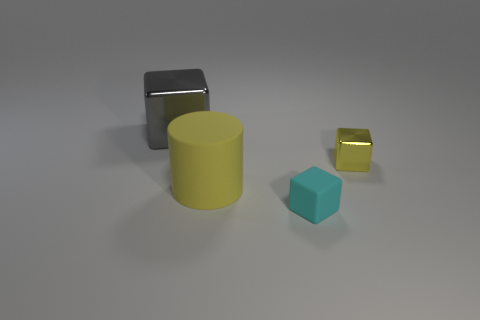Add 1 small yellow metal cylinders. How many objects exist? 5 Subtract all cylinders. How many objects are left? 3 Add 3 big blocks. How many big blocks exist? 4 Subtract 0 gray balls. How many objects are left? 4 Subtract all big yellow objects. Subtract all red matte cubes. How many objects are left? 3 Add 3 gray objects. How many gray objects are left? 4 